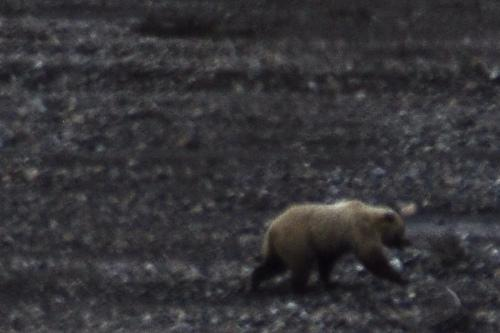Question: what time of day is it?
Choices:
A. Morning.
B. Evening.
C. Night.
D. Noon.
Answer with the letter. Answer: B Question: who is in this picture?
Choices:
A. A dog.
B. A cat.
C. A bear.
D. A cow.
Answer with the letter. Answer: C Question: when will the bear stop walking?
Choices:
A. When it gets tired.
B. When it gets home.
C. Before it sleeps.
D. After it finds food.
Answer with the letter. Answer: D 